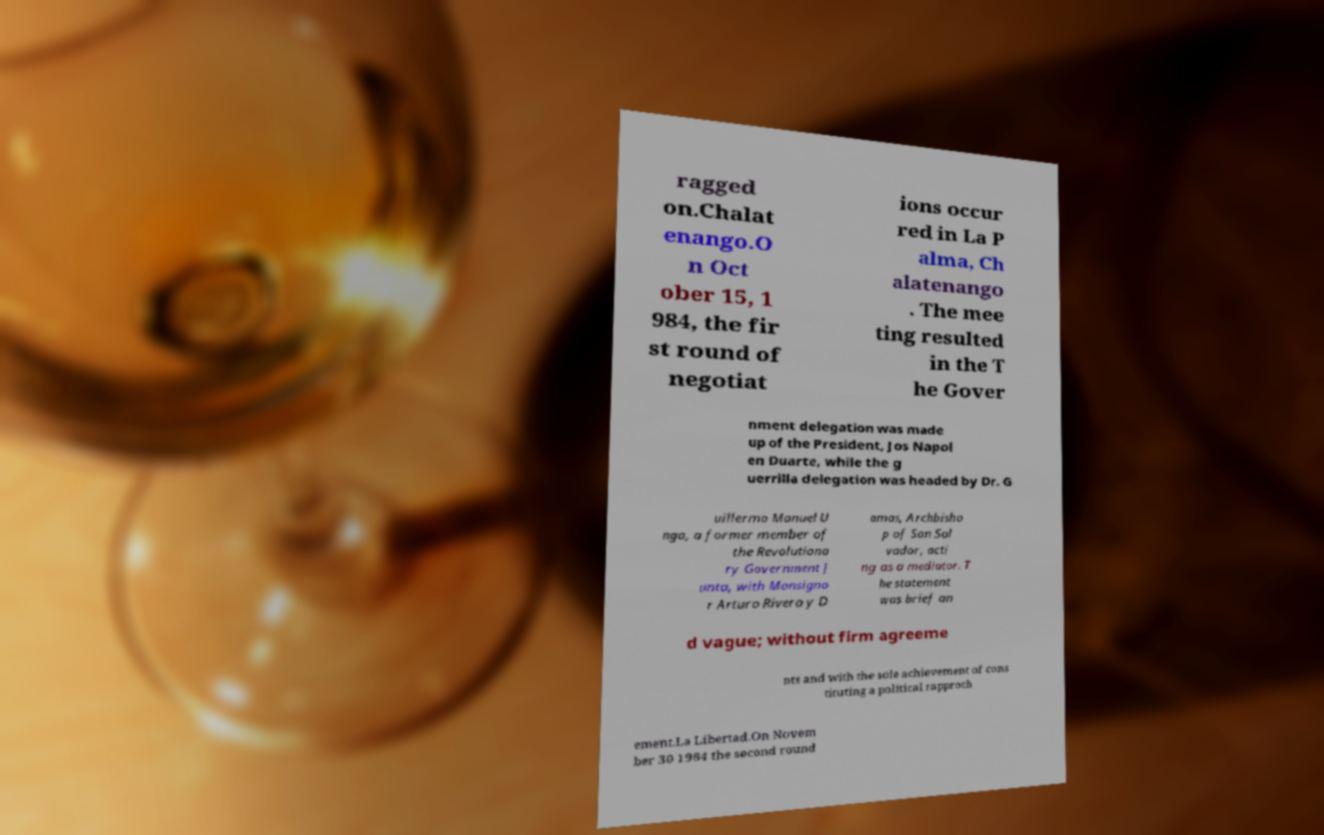For documentation purposes, I need the text within this image transcribed. Could you provide that? ragged on.Chalat enango.O n Oct ober 15, 1 984, the fir st round of negotiat ions occur red in La P alma, Ch alatenango . The mee ting resulted in the T he Gover nment delegation was made up of the President, Jos Napol en Duarte, while the g uerrilla delegation was headed by Dr. G uillermo Manuel U ngo, a former member of the Revolutiona ry Government J unta, with Monsigno r Arturo Rivera y D amas, Archbisho p of San Sal vador, acti ng as a mediator. T he statement was brief an d vague; without firm agreeme nts and with the sole achievement of cons tituting a political rapproch ement.La Libertad.On Novem ber 30 1984 the second round 